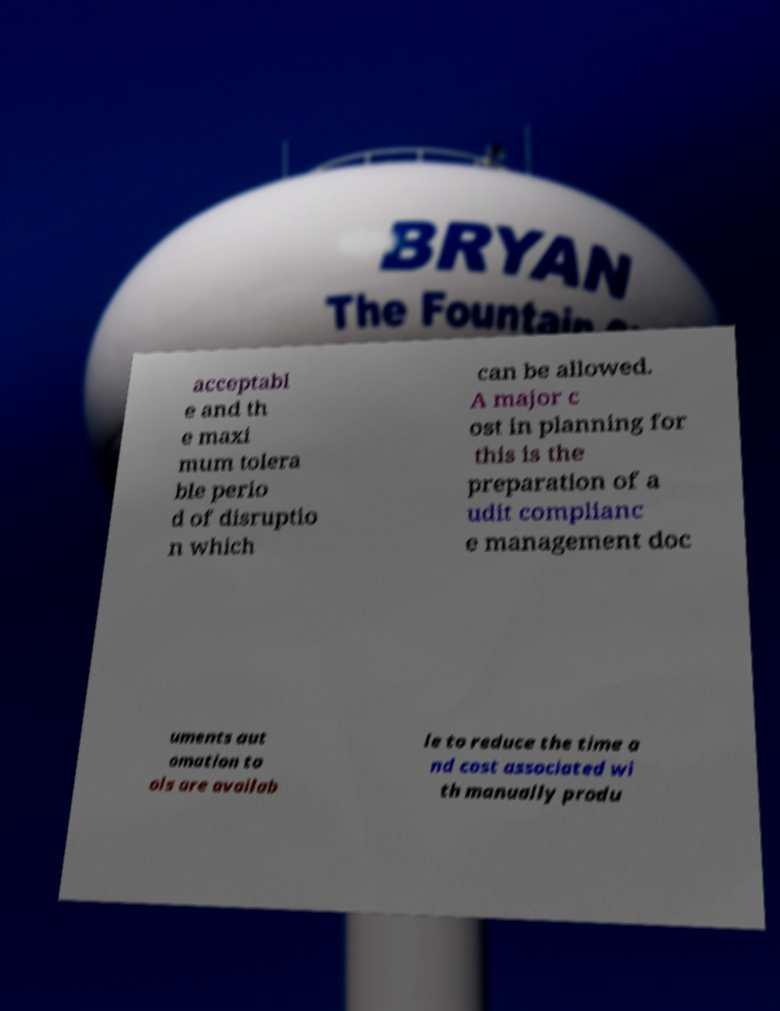I need the written content from this picture converted into text. Can you do that? acceptabl e and th e maxi mum tolera ble perio d of disruptio n which can be allowed. A major c ost in planning for this is the preparation of a udit complianc e management doc uments aut omation to ols are availab le to reduce the time a nd cost associated wi th manually produ 